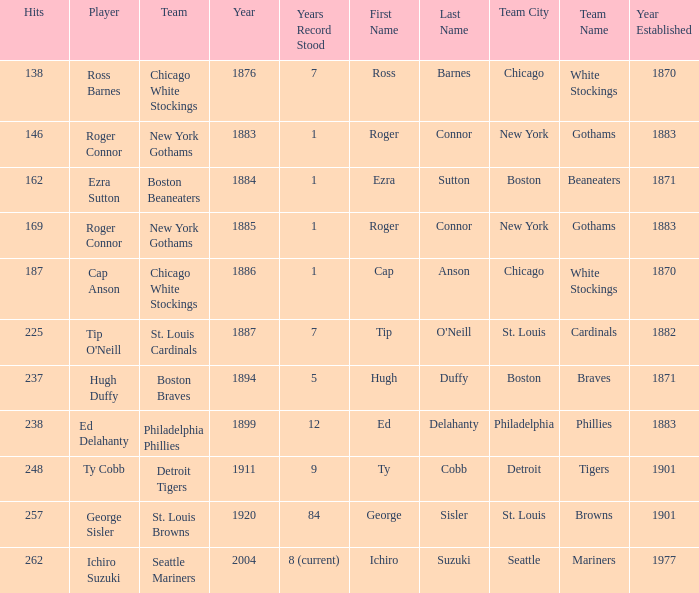Name the hits for years before 1883 138.0. 